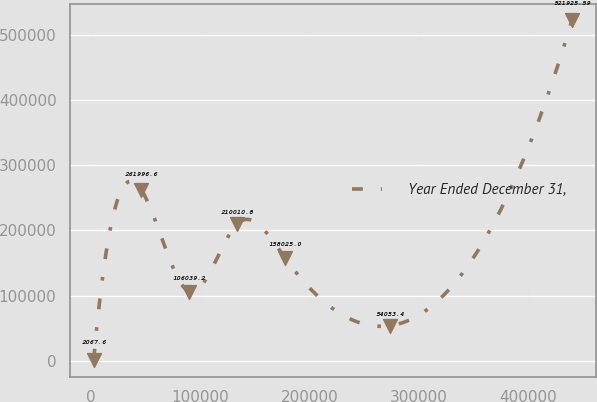Convert chart. <chart><loc_0><loc_0><loc_500><loc_500><line_chart><ecel><fcel>Year Ended December 31,<nl><fcel>2261.56<fcel>2067.6<nl><fcel>46007.4<fcel>261997<nl><fcel>89753.3<fcel>106039<nl><fcel>133499<fcel>210011<nl><fcel>177245<fcel>158025<nl><fcel>273534<fcel>54053.4<nl><fcel>439720<fcel>521926<nl></chart> 